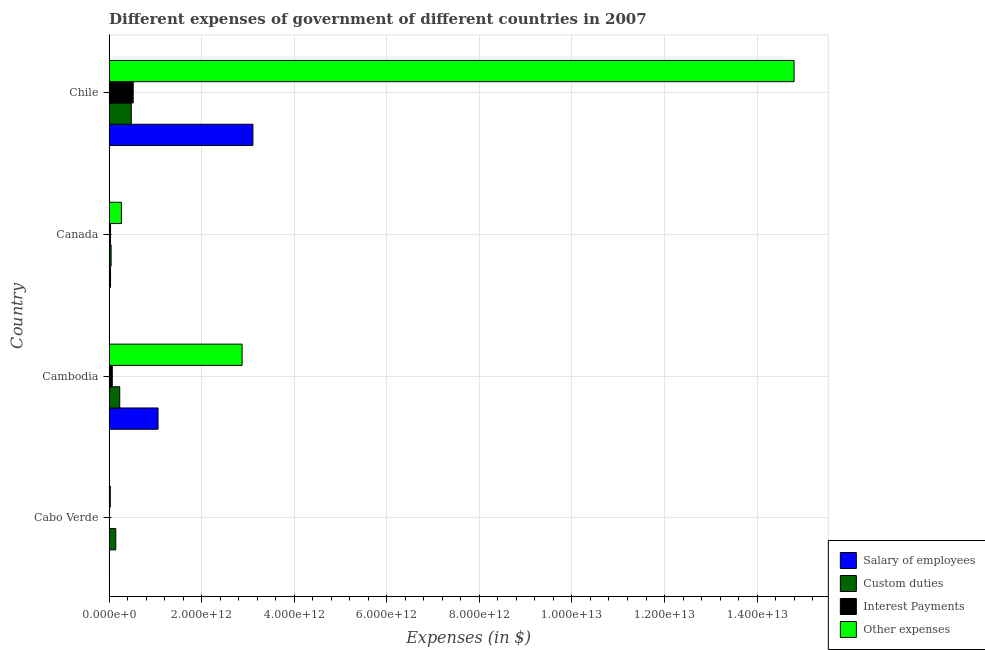How many different coloured bars are there?
Your answer should be compact. 4. Are the number of bars per tick equal to the number of legend labels?
Keep it short and to the point. Yes. Are the number of bars on each tick of the Y-axis equal?
Provide a succinct answer. Yes. How many bars are there on the 3rd tick from the top?
Offer a terse response. 4. What is the label of the 3rd group of bars from the top?
Your answer should be compact. Cambodia. What is the amount spent on custom duties in Chile?
Your answer should be compact. 4.80e+11. Across all countries, what is the maximum amount spent on custom duties?
Offer a very short reply. 4.80e+11. Across all countries, what is the minimum amount spent on salary of employees?
Provide a short and direct response. 9.59e+09. In which country was the amount spent on interest payments minimum?
Your answer should be compact. Cabo Verde. What is the total amount spent on salary of employees in the graph?
Your response must be concise. 4.21e+12. What is the difference between the amount spent on other expenses in Canada and that in Chile?
Keep it short and to the point. -1.45e+13. What is the difference between the amount spent on other expenses in Chile and the amount spent on custom duties in Cabo Verde?
Keep it short and to the point. 1.47e+13. What is the average amount spent on other expenses per country?
Keep it short and to the point. 4.49e+12. What is the difference between the amount spent on interest payments and amount spent on other expenses in Cambodia?
Your answer should be very brief. -2.80e+12. What is the ratio of the amount spent on salary of employees in Cambodia to that in Canada?
Provide a succinct answer. 33.23. What is the difference between the highest and the second highest amount spent on salary of employees?
Offer a very short reply. 2.05e+12. What is the difference between the highest and the lowest amount spent on custom duties?
Make the answer very short. 4.36e+11. In how many countries, is the amount spent on interest payments greater than the average amount spent on interest payments taken over all countries?
Provide a succinct answer. 1. What does the 4th bar from the top in Cambodia represents?
Give a very brief answer. Salary of employees. What does the 3rd bar from the bottom in Chile represents?
Your answer should be compact. Interest Payments. How many bars are there?
Keep it short and to the point. 16. What is the difference between two consecutive major ticks on the X-axis?
Provide a short and direct response. 2.00e+12. Are the values on the major ticks of X-axis written in scientific E-notation?
Your answer should be compact. Yes. Does the graph contain any zero values?
Provide a succinct answer. No. Where does the legend appear in the graph?
Your answer should be compact. Bottom right. How many legend labels are there?
Give a very brief answer. 4. What is the title of the graph?
Your answer should be very brief. Different expenses of government of different countries in 2007. What is the label or title of the X-axis?
Offer a terse response. Expenses (in $). What is the label or title of the Y-axis?
Ensure brevity in your answer.  Country. What is the Expenses (in $) of Salary of employees in Cabo Verde?
Give a very brief answer. 9.59e+09. What is the Expenses (in $) of Custom duties in Cabo Verde?
Provide a succinct answer. 1.45e+11. What is the Expenses (in $) in Interest Payments in Cabo Verde?
Provide a succinct answer. 1.89e+09. What is the Expenses (in $) in Other expenses in Cabo Verde?
Your response must be concise. 2.74e+1. What is the Expenses (in $) of Salary of employees in Cambodia?
Your answer should be very brief. 1.06e+12. What is the Expenses (in $) in Custom duties in Cambodia?
Your answer should be compact. 2.31e+11. What is the Expenses (in $) in Interest Payments in Cambodia?
Ensure brevity in your answer.  6.97e+1. What is the Expenses (in $) of Other expenses in Cambodia?
Offer a very short reply. 2.87e+12. What is the Expenses (in $) of Salary of employees in Canada?
Provide a succinct answer. 3.18e+1. What is the Expenses (in $) in Custom duties in Canada?
Provide a short and direct response. 4.41e+1. What is the Expenses (in $) in Interest Payments in Canada?
Provide a succinct answer. 3.16e+1. What is the Expenses (in $) of Other expenses in Canada?
Your answer should be very brief. 2.67e+11. What is the Expenses (in $) in Salary of employees in Chile?
Keep it short and to the point. 3.11e+12. What is the Expenses (in $) in Custom duties in Chile?
Your answer should be very brief. 4.80e+11. What is the Expenses (in $) in Interest Payments in Chile?
Your answer should be compact. 5.21e+11. What is the Expenses (in $) of Other expenses in Chile?
Your response must be concise. 1.48e+13. Across all countries, what is the maximum Expenses (in $) of Salary of employees?
Your answer should be compact. 3.11e+12. Across all countries, what is the maximum Expenses (in $) in Custom duties?
Give a very brief answer. 4.80e+11. Across all countries, what is the maximum Expenses (in $) of Interest Payments?
Offer a terse response. 5.21e+11. Across all countries, what is the maximum Expenses (in $) of Other expenses?
Give a very brief answer. 1.48e+13. Across all countries, what is the minimum Expenses (in $) in Salary of employees?
Keep it short and to the point. 9.59e+09. Across all countries, what is the minimum Expenses (in $) of Custom duties?
Offer a terse response. 4.41e+1. Across all countries, what is the minimum Expenses (in $) of Interest Payments?
Your answer should be compact. 1.89e+09. Across all countries, what is the minimum Expenses (in $) in Other expenses?
Provide a short and direct response. 2.74e+1. What is the total Expenses (in $) in Salary of employees in the graph?
Make the answer very short. 4.21e+12. What is the total Expenses (in $) of Custom duties in the graph?
Give a very brief answer. 9.00e+11. What is the total Expenses (in $) of Interest Payments in the graph?
Offer a terse response. 6.24e+11. What is the total Expenses (in $) of Other expenses in the graph?
Your answer should be compact. 1.80e+13. What is the difference between the Expenses (in $) of Salary of employees in Cabo Verde and that in Cambodia?
Ensure brevity in your answer.  -1.05e+12. What is the difference between the Expenses (in $) of Custom duties in Cabo Verde and that in Cambodia?
Keep it short and to the point. -8.55e+1. What is the difference between the Expenses (in $) in Interest Payments in Cabo Verde and that in Cambodia?
Give a very brief answer. -6.78e+1. What is the difference between the Expenses (in $) in Other expenses in Cabo Verde and that in Cambodia?
Provide a succinct answer. -2.85e+12. What is the difference between the Expenses (in $) in Salary of employees in Cabo Verde and that in Canada?
Provide a short and direct response. -2.23e+1. What is the difference between the Expenses (in $) in Custom duties in Cabo Verde and that in Canada?
Make the answer very short. 1.01e+11. What is the difference between the Expenses (in $) in Interest Payments in Cabo Verde and that in Canada?
Give a very brief answer. -2.97e+1. What is the difference between the Expenses (in $) in Other expenses in Cabo Verde and that in Canada?
Offer a terse response. -2.39e+11. What is the difference between the Expenses (in $) of Salary of employees in Cabo Verde and that in Chile?
Make the answer very short. -3.10e+12. What is the difference between the Expenses (in $) in Custom duties in Cabo Verde and that in Chile?
Give a very brief answer. -3.35e+11. What is the difference between the Expenses (in $) in Interest Payments in Cabo Verde and that in Chile?
Make the answer very short. -5.19e+11. What is the difference between the Expenses (in $) in Other expenses in Cabo Verde and that in Chile?
Make the answer very short. -1.48e+13. What is the difference between the Expenses (in $) of Salary of employees in Cambodia and that in Canada?
Offer a very short reply. 1.03e+12. What is the difference between the Expenses (in $) in Custom duties in Cambodia and that in Canada?
Offer a very short reply. 1.86e+11. What is the difference between the Expenses (in $) in Interest Payments in Cambodia and that in Canada?
Your answer should be compact. 3.82e+1. What is the difference between the Expenses (in $) of Other expenses in Cambodia and that in Canada?
Make the answer very short. 2.61e+12. What is the difference between the Expenses (in $) in Salary of employees in Cambodia and that in Chile?
Your response must be concise. -2.05e+12. What is the difference between the Expenses (in $) in Custom duties in Cambodia and that in Chile?
Your answer should be compact. -2.49e+11. What is the difference between the Expenses (in $) of Interest Payments in Cambodia and that in Chile?
Make the answer very short. -4.52e+11. What is the difference between the Expenses (in $) in Other expenses in Cambodia and that in Chile?
Ensure brevity in your answer.  -1.19e+13. What is the difference between the Expenses (in $) of Salary of employees in Canada and that in Chile?
Provide a short and direct response. -3.08e+12. What is the difference between the Expenses (in $) of Custom duties in Canada and that in Chile?
Give a very brief answer. -4.36e+11. What is the difference between the Expenses (in $) of Interest Payments in Canada and that in Chile?
Your answer should be compact. -4.90e+11. What is the difference between the Expenses (in $) in Other expenses in Canada and that in Chile?
Offer a very short reply. -1.45e+13. What is the difference between the Expenses (in $) of Salary of employees in Cabo Verde and the Expenses (in $) of Custom duties in Cambodia?
Make the answer very short. -2.21e+11. What is the difference between the Expenses (in $) of Salary of employees in Cabo Verde and the Expenses (in $) of Interest Payments in Cambodia?
Your response must be concise. -6.01e+1. What is the difference between the Expenses (in $) of Salary of employees in Cabo Verde and the Expenses (in $) of Other expenses in Cambodia?
Provide a short and direct response. -2.86e+12. What is the difference between the Expenses (in $) of Custom duties in Cabo Verde and the Expenses (in $) of Interest Payments in Cambodia?
Your answer should be compact. 7.54e+1. What is the difference between the Expenses (in $) in Custom duties in Cabo Verde and the Expenses (in $) in Other expenses in Cambodia?
Ensure brevity in your answer.  -2.73e+12. What is the difference between the Expenses (in $) of Interest Payments in Cabo Verde and the Expenses (in $) of Other expenses in Cambodia?
Offer a very short reply. -2.87e+12. What is the difference between the Expenses (in $) in Salary of employees in Cabo Verde and the Expenses (in $) in Custom duties in Canada?
Give a very brief answer. -3.45e+1. What is the difference between the Expenses (in $) of Salary of employees in Cabo Verde and the Expenses (in $) of Interest Payments in Canada?
Your answer should be very brief. -2.20e+1. What is the difference between the Expenses (in $) of Salary of employees in Cabo Verde and the Expenses (in $) of Other expenses in Canada?
Give a very brief answer. -2.57e+11. What is the difference between the Expenses (in $) in Custom duties in Cabo Verde and the Expenses (in $) in Interest Payments in Canada?
Provide a short and direct response. 1.14e+11. What is the difference between the Expenses (in $) in Custom duties in Cabo Verde and the Expenses (in $) in Other expenses in Canada?
Provide a succinct answer. -1.21e+11. What is the difference between the Expenses (in $) of Interest Payments in Cabo Verde and the Expenses (in $) of Other expenses in Canada?
Offer a terse response. -2.65e+11. What is the difference between the Expenses (in $) in Salary of employees in Cabo Verde and the Expenses (in $) in Custom duties in Chile?
Provide a succinct answer. -4.70e+11. What is the difference between the Expenses (in $) of Salary of employees in Cabo Verde and the Expenses (in $) of Interest Payments in Chile?
Provide a succinct answer. -5.12e+11. What is the difference between the Expenses (in $) of Salary of employees in Cabo Verde and the Expenses (in $) of Other expenses in Chile?
Give a very brief answer. -1.48e+13. What is the difference between the Expenses (in $) in Custom duties in Cabo Verde and the Expenses (in $) in Interest Payments in Chile?
Make the answer very short. -3.76e+11. What is the difference between the Expenses (in $) in Custom duties in Cabo Verde and the Expenses (in $) in Other expenses in Chile?
Ensure brevity in your answer.  -1.47e+13. What is the difference between the Expenses (in $) of Interest Payments in Cabo Verde and the Expenses (in $) of Other expenses in Chile?
Offer a terse response. -1.48e+13. What is the difference between the Expenses (in $) of Salary of employees in Cambodia and the Expenses (in $) of Custom duties in Canada?
Provide a short and direct response. 1.01e+12. What is the difference between the Expenses (in $) in Salary of employees in Cambodia and the Expenses (in $) in Interest Payments in Canada?
Provide a succinct answer. 1.03e+12. What is the difference between the Expenses (in $) in Salary of employees in Cambodia and the Expenses (in $) in Other expenses in Canada?
Your answer should be very brief. 7.92e+11. What is the difference between the Expenses (in $) of Custom duties in Cambodia and the Expenses (in $) of Interest Payments in Canada?
Provide a short and direct response. 1.99e+11. What is the difference between the Expenses (in $) of Custom duties in Cambodia and the Expenses (in $) of Other expenses in Canada?
Make the answer very short. -3.60e+1. What is the difference between the Expenses (in $) of Interest Payments in Cambodia and the Expenses (in $) of Other expenses in Canada?
Provide a short and direct response. -1.97e+11. What is the difference between the Expenses (in $) in Salary of employees in Cambodia and the Expenses (in $) in Custom duties in Chile?
Offer a very short reply. 5.78e+11. What is the difference between the Expenses (in $) in Salary of employees in Cambodia and the Expenses (in $) in Interest Payments in Chile?
Offer a very short reply. 5.37e+11. What is the difference between the Expenses (in $) in Salary of employees in Cambodia and the Expenses (in $) in Other expenses in Chile?
Give a very brief answer. -1.37e+13. What is the difference between the Expenses (in $) in Custom duties in Cambodia and the Expenses (in $) in Interest Payments in Chile?
Provide a succinct answer. -2.91e+11. What is the difference between the Expenses (in $) of Custom duties in Cambodia and the Expenses (in $) of Other expenses in Chile?
Provide a short and direct response. -1.46e+13. What is the difference between the Expenses (in $) of Interest Payments in Cambodia and the Expenses (in $) of Other expenses in Chile?
Your answer should be compact. -1.47e+13. What is the difference between the Expenses (in $) of Salary of employees in Canada and the Expenses (in $) of Custom duties in Chile?
Offer a very short reply. -4.48e+11. What is the difference between the Expenses (in $) of Salary of employees in Canada and the Expenses (in $) of Interest Payments in Chile?
Offer a very short reply. -4.89e+11. What is the difference between the Expenses (in $) in Salary of employees in Canada and the Expenses (in $) in Other expenses in Chile?
Offer a very short reply. -1.48e+13. What is the difference between the Expenses (in $) in Custom duties in Canada and the Expenses (in $) in Interest Payments in Chile?
Offer a very short reply. -4.77e+11. What is the difference between the Expenses (in $) of Custom duties in Canada and the Expenses (in $) of Other expenses in Chile?
Make the answer very short. -1.48e+13. What is the difference between the Expenses (in $) of Interest Payments in Canada and the Expenses (in $) of Other expenses in Chile?
Your answer should be compact. -1.48e+13. What is the average Expenses (in $) of Salary of employees per country?
Give a very brief answer. 1.05e+12. What is the average Expenses (in $) of Custom duties per country?
Your response must be concise. 2.25e+11. What is the average Expenses (in $) of Interest Payments per country?
Offer a terse response. 1.56e+11. What is the average Expenses (in $) in Other expenses per country?
Ensure brevity in your answer.  4.49e+12. What is the difference between the Expenses (in $) of Salary of employees and Expenses (in $) of Custom duties in Cabo Verde?
Keep it short and to the point. -1.35e+11. What is the difference between the Expenses (in $) of Salary of employees and Expenses (in $) of Interest Payments in Cabo Verde?
Offer a terse response. 7.70e+09. What is the difference between the Expenses (in $) in Salary of employees and Expenses (in $) in Other expenses in Cabo Verde?
Offer a terse response. -1.78e+1. What is the difference between the Expenses (in $) in Custom duties and Expenses (in $) in Interest Payments in Cabo Verde?
Your response must be concise. 1.43e+11. What is the difference between the Expenses (in $) in Custom duties and Expenses (in $) in Other expenses in Cabo Verde?
Keep it short and to the point. 1.18e+11. What is the difference between the Expenses (in $) of Interest Payments and Expenses (in $) of Other expenses in Cabo Verde?
Your answer should be compact. -2.55e+1. What is the difference between the Expenses (in $) in Salary of employees and Expenses (in $) in Custom duties in Cambodia?
Provide a succinct answer. 8.28e+11. What is the difference between the Expenses (in $) of Salary of employees and Expenses (in $) of Interest Payments in Cambodia?
Your answer should be compact. 9.88e+11. What is the difference between the Expenses (in $) in Salary of employees and Expenses (in $) in Other expenses in Cambodia?
Give a very brief answer. -1.82e+12. What is the difference between the Expenses (in $) of Custom duties and Expenses (in $) of Interest Payments in Cambodia?
Provide a succinct answer. 1.61e+11. What is the difference between the Expenses (in $) of Custom duties and Expenses (in $) of Other expenses in Cambodia?
Your response must be concise. -2.64e+12. What is the difference between the Expenses (in $) in Interest Payments and Expenses (in $) in Other expenses in Cambodia?
Make the answer very short. -2.80e+12. What is the difference between the Expenses (in $) in Salary of employees and Expenses (in $) in Custom duties in Canada?
Offer a very short reply. -1.23e+1. What is the difference between the Expenses (in $) of Salary of employees and Expenses (in $) of Interest Payments in Canada?
Offer a terse response. 2.90e+08. What is the difference between the Expenses (in $) of Salary of employees and Expenses (in $) of Other expenses in Canada?
Offer a very short reply. -2.35e+11. What is the difference between the Expenses (in $) of Custom duties and Expenses (in $) of Interest Payments in Canada?
Keep it short and to the point. 1.26e+1. What is the difference between the Expenses (in $) of Custom duties and Expenses (in $) of Other expenses in Canada?
Your response must be concise. -2.22e+11. What is the difference between the Expenses (in $) of Interest Payments and Expenses (in $) of Other expenses in Canada?
Your response must be concise. -2.35e+11. What is the difference between the Expenses (in $) in Salary of employees and Expenses (in $) in Custom duties in Chile?
Your response must be concise. 2.63e+12. What is the difference between the Expenses (in $) of Salary of employees and Expenses (in $) of Interest Payments in Chile?
Make the answer very short. 2.59e+12. What is the difference between the Expenses (in $) in Salary of employees and Expenses (in $) in Other expenses in Chile?
Your answer should be compact. -1.17e+13. What is the difference between the Expenses (in $) of Custom duties and Expenses (in $) of Interest Payments in Chile?
Your answer should be compact. -4.15e+1. What is the difference between the Expenses (in $) of Custom duties and Expenses (in $) of Other expenses in Chile?
Provide a short and direct response. -1.43e+13. What is the difference between the Expenses (in $) in Interest Payments and Expenses (in $) in Other expenses in Chile?
Give a very brief answer. -1.43e+13. What is the ratio of the Expenses (in $) of Salary of employees in Cabo Verde to that in Cambodia?
Provide a succinct answer. 0.01. What is the ratio of the Expenses (in $) of Custom duties in Cabo Verde to that in Cambodia?
Make the answer very short. 0.63. What is the ratio of the Expenses (in $) of Interest Payments in Cabo Verde to that in Cambodia?
Provide a short and direct response. 0.03. What is the ratio of the Expenses (in $) of Other expenses in Cabo Verde to that in Cambodia?
Offer a terse response. 0.01. What is the ratio of the Expenses (in $) in Salary of employees in Cabo Verde to that in Canada?
Give a very brief answer. 0.3. What is the ratio of the Expenses (in $) of Custom duties in Cabo Verde to that in Canada?
Keep it short and to the point. 3.29. What is the ratio of the Expenses (in $) in Interest Payments in Cabo Verde to that in Canada?
Keep it short and to the point. 0.06. What is the ratio of the Expenses (in $) of Other expenses in Cabo Verde to that in Canada?
Your answer should be very brief. 0.1. What is the ratio of the Expenses (in $) in Salary of employees in Cabo Verde to that in Chile?
Ensure brevity in your answer.  0. What is the ratio of the Expenses (in $) of Custom duties in Cabo Verde to that in Chile?
Make the answer very short. 0.3. What is the ratio of the Expenses (in $) of Interest Payments in Cabo Verde to that in Chile?
Your response must be concise. 0. What is the ratio of the Expenses (in $) in Other expenses in Cabo Verde to that in Chile?
Keep it short and to the point. 0. What is the ratio of the Expenses (in $) in Salary of employees in Cambodia to that in Canada?
Ensure brevity in your answer.  33.23. What is the ratio of the Expenses (in $) in Custom duties in Cambodia to that in Canada?
Ensure brevity in your answer.  5.23. What is the ratio of the Expenses (in $) of Interest Payments in Cambodia to that in Canada?
Your response must be concise. 2.21. What is the ratio of the Expenses (in $) of Other expenses in Cambodia to that in Canada?
Your response must be concise. 10.78. What is the ratio of the Expenses (in $) in Salary of employees in Cambodia to that in Chile?
Make the answer very short. 0.34. What is the ratio of the Expenses (in $) of Custom duties in Cambodia to that in Chile?
Give a very brief answer. 0.48. What is the ratio of the Expenses (in $) of Interest Payments in Cambodia to that in Chile?
Your response must be concise. 0.13. What is the ratio of the Expenses (in $) in Other expenses in Cambodia to that in Chile?
Offer a terse response. 0.19. What is the ratio of the Expenses (in $) in Salary of employees in Canada to that in Chile?
Offer a terse response. 0.01. What is the ratio of the Expenses (in $) of Custom duties in Canada to that in Chile?
Give a very brief answer. 0.09. What is the ratio of the Expenses (in $) of Interest Payments in Canada to that in Chile?
Make the answer very short. 0.06. What is the ratio of the Expenses (in $) in Other expenses in Canada to that in Chile?
Offer a terse response. 0.02. What is the difference between the highest and the second highest Expenses (in $) of Salary of employees?
Give a very brief answer. 2.05e+12. What is the difference between the highest and the second highest Expenses (in $) of Custom duties?
Provide a short and direct response. 2.49e+11. What is the difference between the highest and the second highest Expenses (in $) of Interest Payments?
Your answer should be compact. 4.52e+11. What is the difference between the highest and the second highest Expenses (in $) of Other expenses?
Keep it short and to the point. 1.19e+13. What is the difference between the highest and the lowest Expenses (in $) in Salary of employees?
Offer a very short reply. 3.10e+12. What is the difference between the highest and the lowest Expenses (in $) of Custom duties?
Offer a very short reply. 4.36e+11. What is the difference between the highest and the lowest Expenses (in $) in Interest Payments?
Your response must be concise. 5.19e+11. What is the difference between the highest and the lowest Expenses (in $) in Other expenses?
Provide a succinct answer. 1.48e+13. 